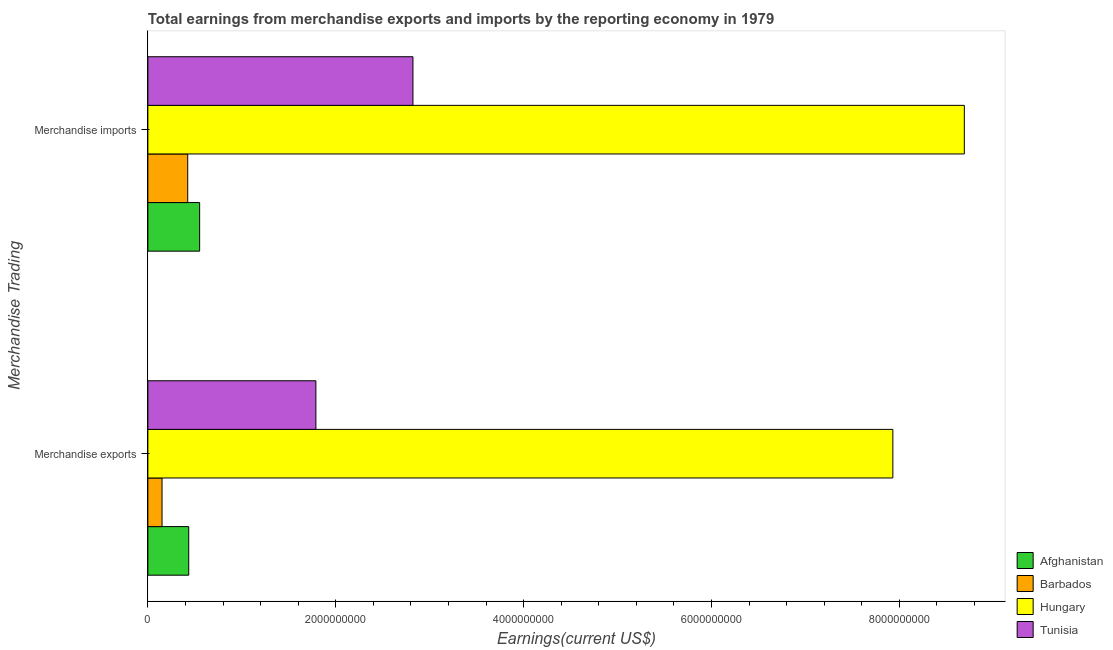How many different coloured bars are there?
Ensure brevity in your answer.  4. Are the number of bars per tick equal to the number of legend labels?
Provide a short and direct response. Yes. What is the label of the 1st group of bars from the top?
Ensure brevity in your answer.  Merchandise imports. What is the earnings from merchandise imports in Tunisia?
Provide a short and direct response. 2.82e+09. Across all countries, what is the maximum earnings from merchandise exports?
Provide a short and direct response. 7.93e+09. Across all countries, what is the minimum earnings from merchandise exports?
Offer a terse response. 1.51e+08. In which country was the earnings from merchandise imports maximum?
Provide a short and direct response. Hungary. In which country was the earnings from merchandise imports minimum?
Keep it short and to the point. Barbados. What is the total earnings from merchandise exports in the graph?
Your answer should be compact. 1.03e+1. What is the difference between the earnings from merchandise exports in Afghanistan and that in Tunisia?
Your answer should be compact. -1.35e+09. What is the difference between the earnings from merchandise exports in Afghanistan and the earnings from merchandise imports in Hungary?
Ensure brevity in your answer.  -8.26e+09. What is the average earnings from merchandise imports per country?
Offer a terse response. 3.12e+09. What is the difference between the earnings from merchandise imports and earnings from merchandise exports in Tunisia?
Provide a short and direct response. 1.03e+09. What is the ratio of the earnings from merchandise exports in Barbados to that in Afghanistan?
Provide a succinct answer. 0.35. In how many countries, is the earnings from merchandise exports greater than the average earnings from merchandise exports taken over all countries?
Offer a terse response. 1. What does the 1st bar from the top in Merchandise imports represents?
Your answer should be very brief. Tunisia. What does the 4th bar from the bottom in Merchandise exports represents?
Make the answer very short. Tunisia. How many bars are there?
Ensure brevity in your answer.  8. Are all the bars in the graph horizontal?
Offer a terse response. Yes. What is the difference between two consecutive major ticks on the X-axis?
Keep it short and to the point. 2.00e+09. Does the graph contain any zero values?
Ensure brevity in your answer.  No. Does the graph contain grids?
Give a very brief answer. No. How many legend labels are there?
Keep it short and to the point. 4. What is the title of the graph?
Your answer should be very brief. Total earnings from merchandise exports and imports by the reporting economy in 1979. What is the label or title of the X-axis?
Ensure brevity in your answer.  Earnings(current US$). What is the label or title of the Y-axis?
Provide a succinct answer. Merchandise Trading. What is the Earnings(current US$) of Afghanistan in Merchandise exports?
Provide a short and direct response. 4.35e+08. What is the Earnings(current US$) in Barbados in Merchandise exports?
Provide a succinct answer. 1.51e+08. What is the Earnings(current US$) in Hungary in Merchandise exports?
Provide a succinct answer. 7.93e+09. What is the Earnings(current US$) of Tunisia in Merchandise exports?
Your response must be concise. 1.79e+09. What is the Earnings(current US$) in Afghanistan in Merchandise imports?
Make the answer very short. 5.51e+08. What is the Earnings(current US$) in Barbados in Merchandise imports?
Your answer should be very brief. 4.24e+08. What is the Earnings(current US$) in Hungary in Merchandise imports?
Make the answer very short. 8.69e+09. What is the Earnings(current US$) of Tunisia in Merchandise imports?
Provide a short and direct response. 2.82e+09. Across all Merchandise Trading, what is the maximum Earnings(current US$) of Afghanistan?
Keep it short and to the point. 5.51e+08. Across all Merchandise Trading, what is the maximum Earnings(current US$) of Barbados?
Offer a terse response. 4.24e+08. Across all Merchandise Trading, what is the maximum Earnings(current US$) in Hungary?
Make the answer very short. 8.69e+09. Across all Merchandise Trading, what is the maximum Earnings(current US$) in Tunisia?
Ensure brevity in your answer.  2.82e+09. Across all Merchandise Trading, what is the minimum Earnings(current US$) in Afghanistan?
Offer a very short reply. 4.35e+08. Across all Merchandise Trading, what is the minimum Earnings(current US$) in Barbados?
Provide a short and direct response. 1.51e+08. Across all Merchandise Trading, what is the minimum Earnings(current US$) in Hungary?
Your answer should be very brief. 7.93e+09. Across all Merchandise Trading, what is the minimum Earnings(current US$) of Tunisia?
Your answer should be compact. 1.79e+09. What is the total Earnings(current US$) of Afghanistan in the graph?
Your answer should be very brief. 9.86e+08. What is the total Earnings(current US$) in Barbados in the graph?
Provide a short and direct response. 5.75e+08. What is the total Earnings(current US$) in Hungary in the graph?
Make the answer very short. 1.66e+1. What is the total Earnings(current US$) of Tunisia in the graph?
Offer a terse response. 4.61e+09. What is the difference between the Earnings(current US$) in Afghanistan in Merchandise exports and that in Merchandise imports?
Offer a very short reply. -1.16e+08. What is the difference between the Earnings(current US$) in Barbados in Merchandise exports and that in Merchandise imports?
Your answer should be very brief. -2.73e+08. What is the difference between the Earnings(current US$) in Hungary in Merchandise exports and that in Merchandise imports?
Make the answer very short. -7.61e+08. What is the difference between the Earnings(current US$) in Tunisia in Merchandise exports and that in Merchandise imports?
Offer a very short reply. -1.03e+09. What is the difference between the Earnings(current US$) in Afghanistan in Merchandise exports and the Earnings(current US$) in Barbados in Merchandise imports?
Ensure brevity in your answer.  1.07e+07. What is the difference between the Earnings(current US$) in Afghanistan in Merchandise exports and the Earnings(current US$) in Hungary in Merchandise imports?
Your answer should be compact. -8.26e+09. What is the difference between the Earnings(current US$) of Afghanistan in Merchandise exports and the Earnings(current US$) of Tunisia in Merchandise imports?
Your answer should be very brief. -2.39e+09. What is the difference between the Earnings(current US$) of Barbados in Merchandise exports and the Earnings(current US$) of Hungary in Merchandise imports?
Make the answer very short. -8.54e+09. What is the difference between the Earnings(current US$) of Barbados in Merchandise exports and the Earnings(current US$) of Tunisia in Merchandise imports?
Provide a short and direct response. -2.67e+09. What is the difference between the Earnings(current US$) in Hungary in Merchandise exports and the Earnings(current US$) in Tunisia in Merchandise imports?
Your answer should be very brief. 5.11e+09. What is the average Earnings(current US$) of Afghanistan per Merchandise Trading?
Keep it short and to the point. 4.93e+08. What is the average Earnings(current US$) in Barbados per Merchandise Trading?
Offer a terse response. 2.88e+08. What is the average Earnings(current US$) of Hungary per Merchandise Trading?
Your answer should be very brief. 8.31e+09. What is the average Earnings(current US$) of Tunisia per Merchandise Trading?
Provide a succinct answer. 2.31e+09. What is the difference between the Earnings(current US$) in Afghanistan and Earnings(current US$) in Barbados in Merchandise exports?
Provide a succinct answer. 2.84e+08. What is the difference between the Earnings(current US$) in Afghanistan and Earnings(current US$) in Hungary in Merchandise exports?
Ensure brevity in your answer.  -7.50e+09. What is the difference between the Earnings(current US$) in Afghanistan and Earnings(current US$) in Tunisia in Merchandise exports?
Your answer should be very brief. -1.35e+09. What is the difference between the Earnings(current US$) in Barbados and Earnings(current US$) in Hungary in Merchandise exports?
Provide a short and direct response. -7.78e+09. What is the difference between the Earnings(current US$) of Barbados and Earnings(current US$) of Tunisia in Merchandise exports?
Provide a short and direct response. -1.64e+09. What is the difference between the Earnings(current US$) in Hungary and Earnings(current US$) in Tunisia in Merchandise exports?
Keep it short and to the point. 6.14e+09. What is the difference between the Earnings(current US$) of Afghanistan and Earnings(current US$) of Barbados in Merchandise imports?
Ensure brevity in your answer.  1.27e+08. What is the difference between the Earnings(current US$) in Afghanistan and Earnings(current US$) in Hungary in Merchandise imports?
Give a very brief answer. -8.14e+09. What is the difference between the Earnings(current US$) of Afghanistan and Earnings(current US$) of Tunisia in Merchandise imports?
Provide a succinct answer. -2.27e+09. What is the difference between the Earnings(current US$) of Barbados and Earnings(current US$) of Hungary in Merchandise imports?
Offer a very short reply. -8.27e+09. What is the difference between the Earnings(current US$) of Barbados and Earnings(current US$) of Tunisia in Merchandise imports?
Ensure brevity in your answer.  -2.40e+09. What is the difference between the Earnings(current US$) in Hungary and Earnings(current US$) in Tunisia in Merchandise imports?
Offer a terse response. 5.87e+09. What is the ratio of the Earnings(current US$) of Afghanistan in Merchandise exports to that in Merchandise imports?
Give a very brief answer. 0.79. What is the ratio of the Earnings(current US$) of Barbados in Merchandise exports to that in Merchandise imports?
Your response must be concise. 0.36. What is the ratio of the Earnings(current US$) in Hungary in Merchandise exports to that in Merchandise imports?
Keep it short and to the point. 0.91. What is the ratio of the Earnings(current US$) of Tunisia in Merchandise exports to that in Merchandise imports?
Provide a succinct answer. 0.63. What is the difference between the highest and the second highest Earnings(current US$) in Afghanistan?
Offer a terse response. 1.16e+08. What is the difference between the highest and the second highest Earnings(current US$) in Barbados?
Ensure brevity in your answer.  2.73e+08. What is the difference between the highest and the second highest Earnings(current US$) of Hungary?
Offer a terse response. 7.61e+08. What is the difference between the highest and the second highest Earnings(current US$) in Tunisia?
Provide a short and direct response. 1.03e+09. What is the difference between the highest and the lowest Earnings(current US$) of Afghanistan?
Keep it short and to the point. 1.16e+08. What is the difference between the highest and the lowest Earnings(current US$) in Barbados?
Your response must be concise. 2.73e+08. What is the difference between the highest and the lowest Earnings(current US$) in Hungary?
Ensure brevity in your answer.  7.61e+08. What is the difference between the highest and the lowest Earnings(current US$) of Tunisia?
Keep it short and to the point. 1.03e+09. 